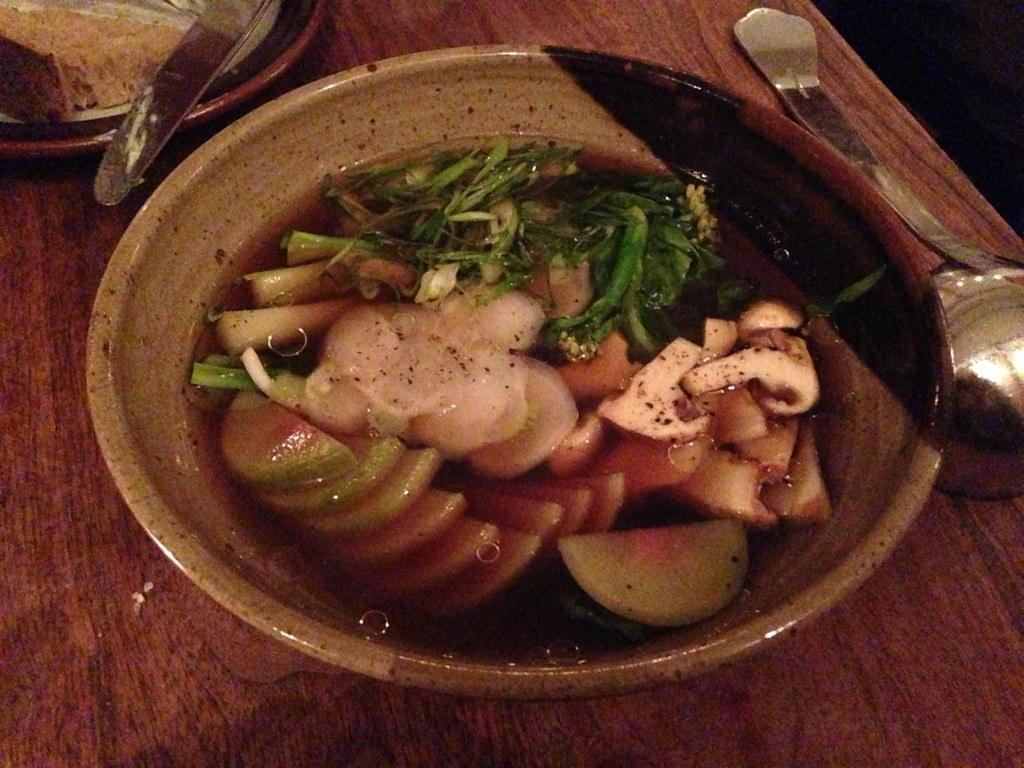What type of table is in the image? There is a wooden table in the image. What is on top of the table? There is a bowl, a plate, and stainless steel cookware with a handle on the table. What is in the bowl? There are vegetables and water in the bowl. What type of government is depicted in the image? There is no depiction of a government in the image; it features a wooden table with various items on it. 